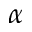Convert formula to latex. <formula><loc_0><loc_0><loc_500><loc_500>\alpha</formula> 